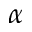Convert formula to latex. <formula><loc_0><loc_0><loc_500><loc_500>\alpha</formula> 